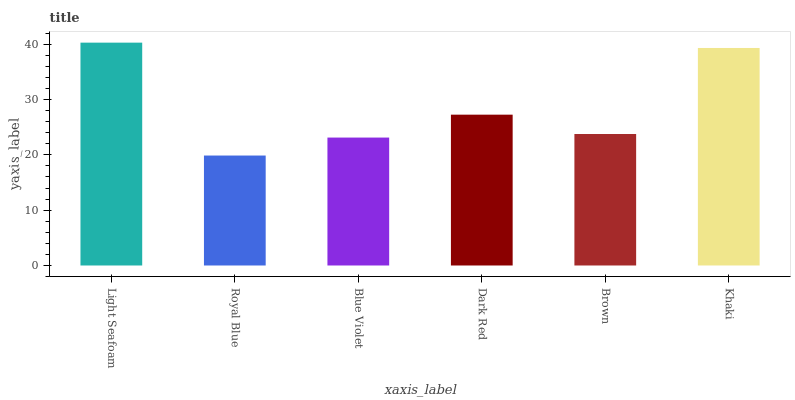Is Royal Blue the minimum?
Answer yes or no. Yes. Is Light Seafoam the maximum?
Answer yes or no. Yes. Is Blue Violet the minimum?
Answer yes or no. No. Is Blue Violet the maximum?
Answer yes or no. No. Is Blue Violet greater than Royal Blue?
Answer yes or no. Yes. Is Royal Blue less than Blue Violet?
Answer yes or no. Yes. Is Royal Blue greater than Blue Violet?
Answer yes or no. No. Is Blue Violet less than Royal Blue?
Answer yes or no. No. Is Dark Red the high median?
Answer yes or no. Yes. Is Brown the low median?
Answer yes or no. Yes. Is Light Seafoam the high median?
Answer yes or no. No. Is Royal Blue the low median?
Answer yes or no. No. 